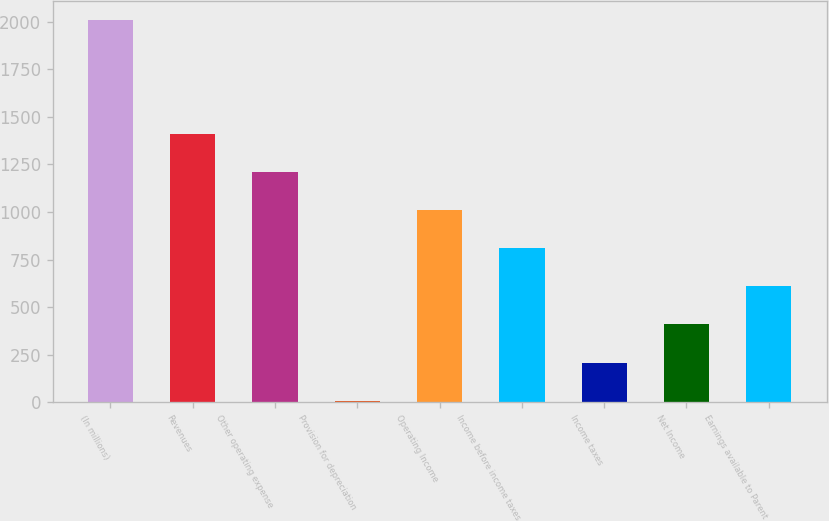Convert chart to OTSL. <chart><loc_0><loc_0><loc_500><loc_500><bar_chart><fcel>(In millions)<fcel>Revenues<fcel>Other operating expense<fcel>Provision for depreciation<fcel>Operating Income<fcel>Income before income taxes<fcel>Income taxes<fcel>Net Income<fcel>Earnings available to Parent<nl><fcel>2011<fcel>1410.1<fcel>1209.8<fcel>8<fcel>1009.5<fcel>809.2<fcel>208.3<fcel>408.6<fcel>608.9<nl></chart> 